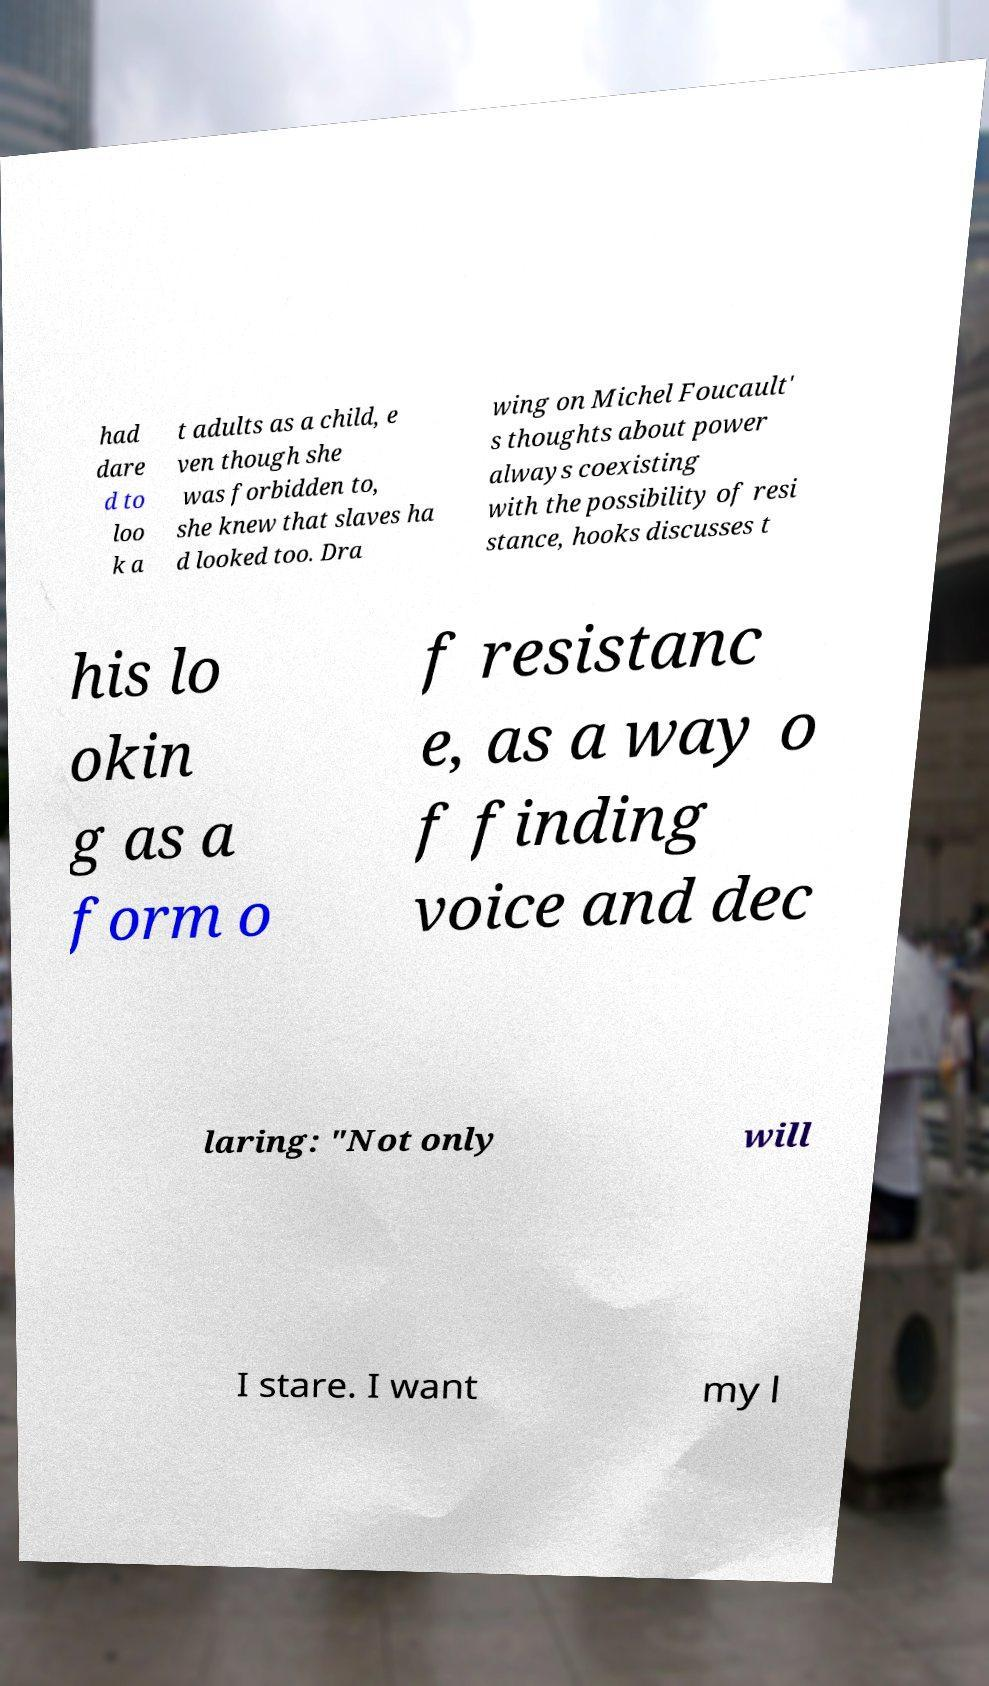I need the written content from this picture converted into text. Can you do that? had dare d to loo k a t adults as a child, e ven though she was forbidden to, she knew that slaves ha d looked too. Dra wing on Michel Foucault' s thoughts about power always coexisting with the possibility of resi stance, hooks discusses t his lo okin g as a form o f resistanc e, as a way o f finding voice and dec laring: "Not only will I stare. I want my l 